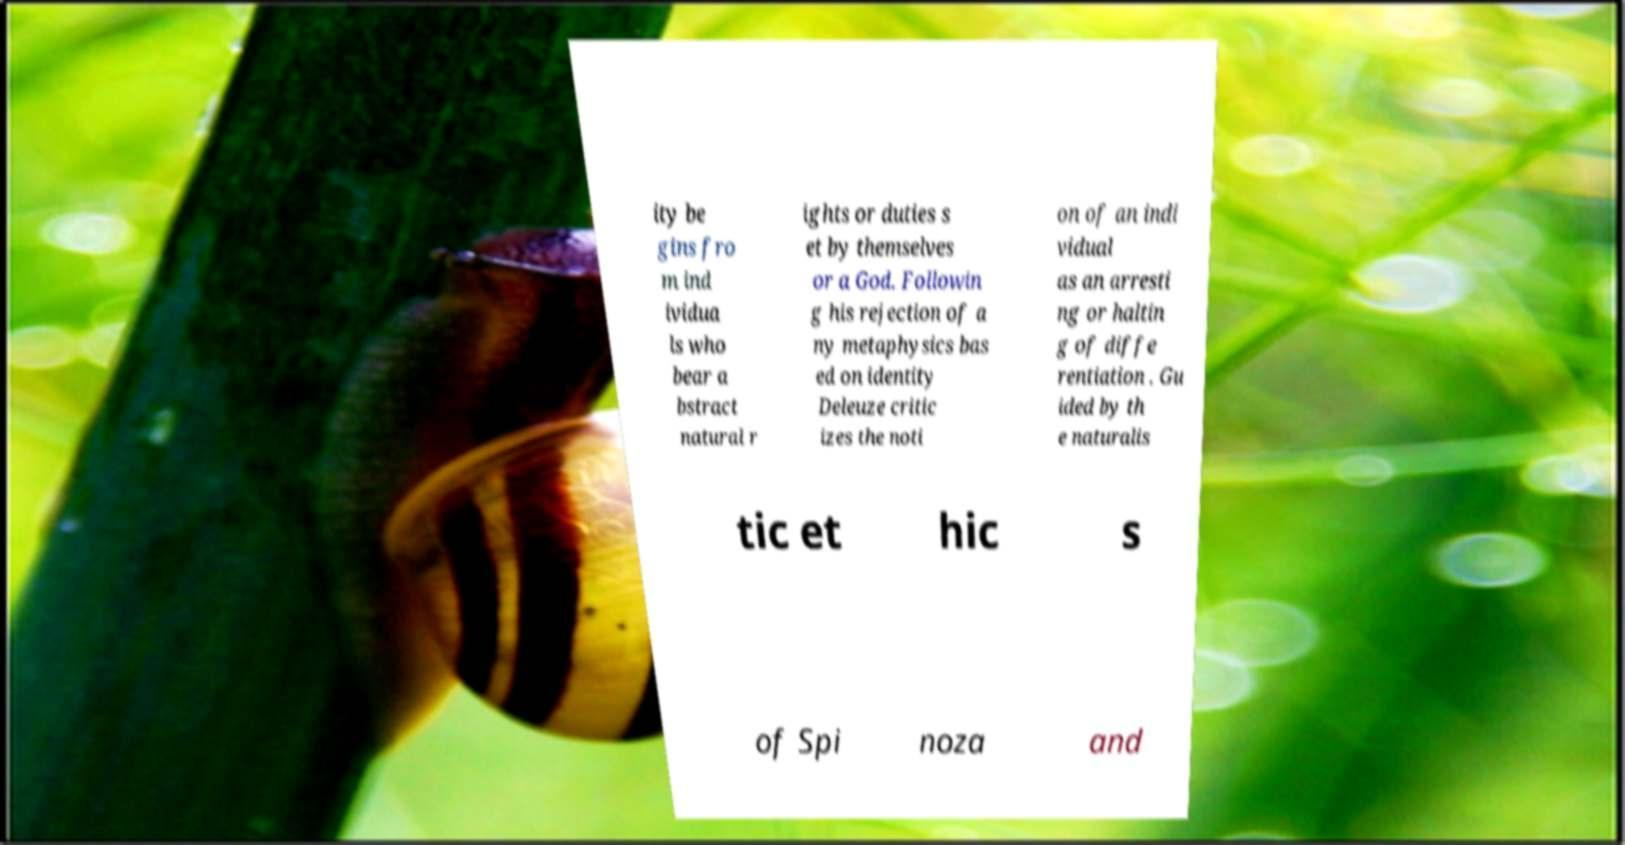Please identify and transcribe the text found in this image. ity be gins fro m ind ividua ls who bear a bstract natural r ights or duties s et by themselves or a God. Followin g his rejection of a ny metaphysics bas ed on identity Deleuze critic izes the noti on of an indi vidual as an arresti ng or haltin g of diffe rentiation . Gu ided by th e naturalis tic et hic s of Spi noza and 